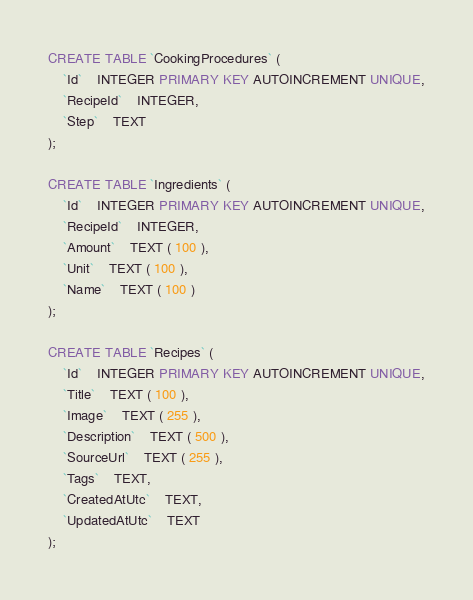Convert code to text. <code><loc_0><loc_0><loc_500><loc_500><_SQL_>CREATE TABLE `CookingProcedures` (
	`Id`	INTEGER PRIMARY KEY AUTOINCREMENT UNIQUE,
	`RecipeId`	INTEGER,
	`Step`	TEXT
);

CREATE TABLE `Ingredients` (
	`Id`	INTEGER PRIMARY KEY AUTOINCREMENT UNIQUE,
	`RecipeId`	INTEGER,
	`Amount`	TEXT ( 100 ),
	`Unit`	TEXT ( 100 ),
	`Name`	TEXT ( 100 )
);

CREATE TABLE `Recipes` (
	`Id`	INTEGER PRIMARY KEY AUTOINCREMENT UNIQUE,
	`Title`	TEXT ( 100 ),
	`Image`	TEXT ( 255 ),
	`Description`	TEXT ( 500 ),
	`SourceUrl`	TEXT ( 255 ),
	`Tags`	TEXT,
	`CreatedAtUtc`	TEXT,
	`UpdatedAtUtc`	TEXT
);

</code> 